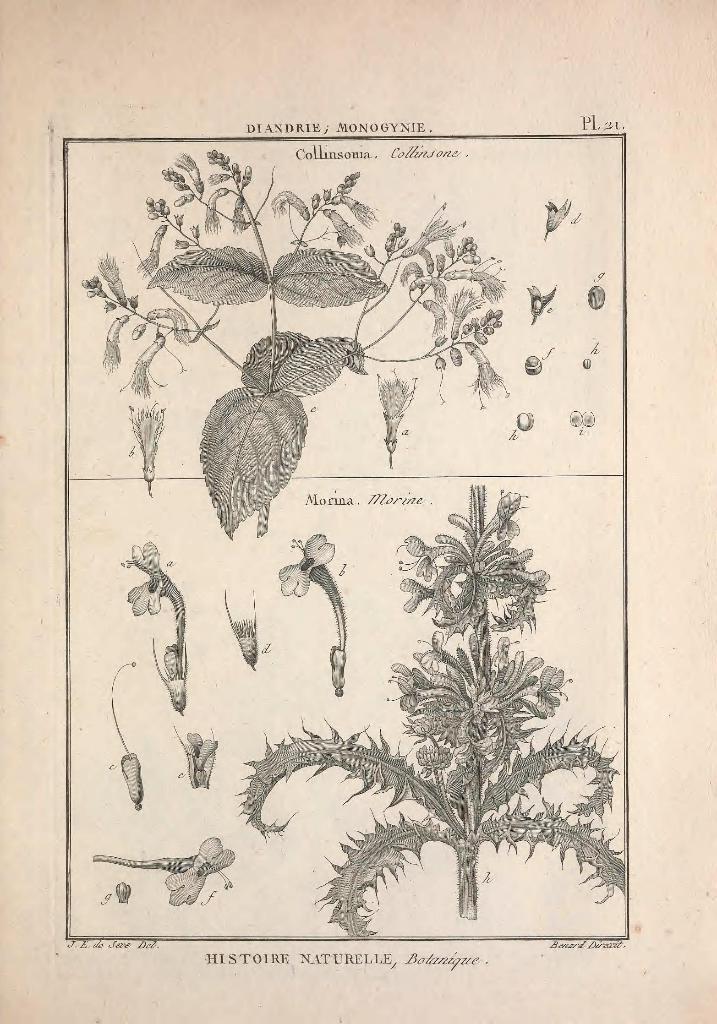Can you describe this image briefly? In this image we can see pictures of plants and flowers printed on the paper. At the bottom there is text. 